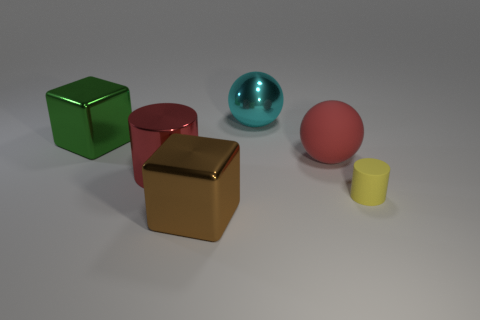Add 4 large brown metallic things. How many objects exist? 10 Subtract all cylinders. How many objects are left? 4 Subtract all brown blocks. How many blocks are left? 1 Subtract 1 red cylinders. How many objects are left? 5 Subtract 2 cubes. How many cubes are left? 0 Subtract all purple cylinders. Subtract all cyan balls. How many cylinders are left? 2 Subtract all cyan cubes. How many red spheres are left? 1 Subtract all matte things. Subtract all cyan shiny things. How many objects are left? 3 Add 2 big cyan balls. How many big cyan balls are left? 3 Add 4 big brown shiny cubes. How many big brown shiny cubes exist? 5 